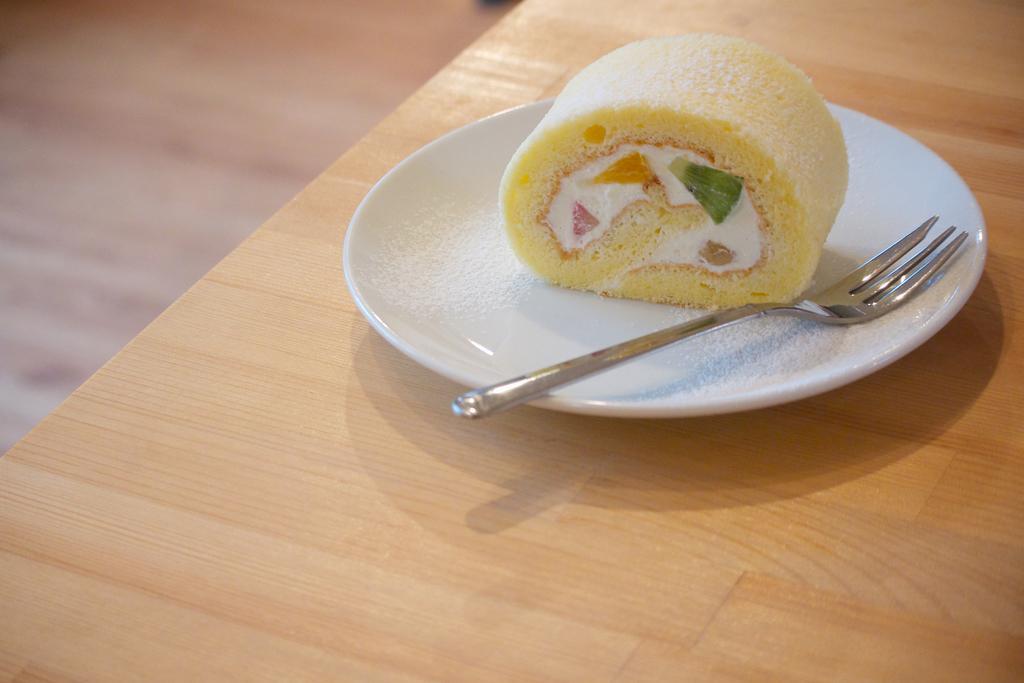Could you give a brief overview of what you see in this image? In this picture we can see a table in the front, there is a plate present on the table, we can see a fork and some food in this plate, there is a blurry background. 